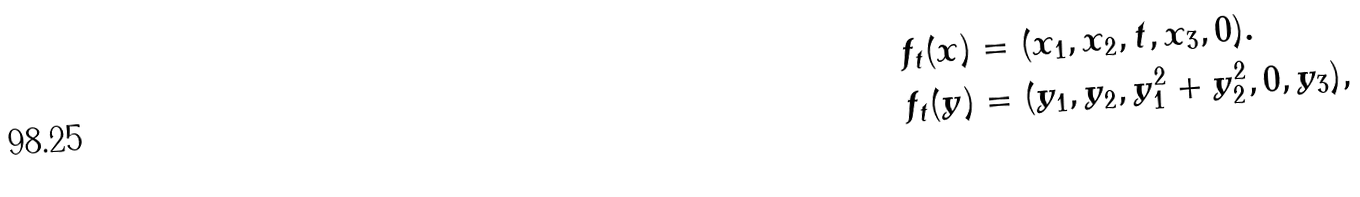Convert formula to latex. <formula><loc_0><loc_0><loc_500><loc_500>f _ { t } ( x ) & = ( x _ { 1 } , x _ { 2 } , t , x _ { 3 } , 0 ) . \\ f _ { t } ( y ) & = ( y _ { 1 } , y _ { 2 } , y _ { 1 } ^ { 2 } + y _ { 2 } ^ { 2 } , 0 , y _ { 3 } ) ,</formula> 